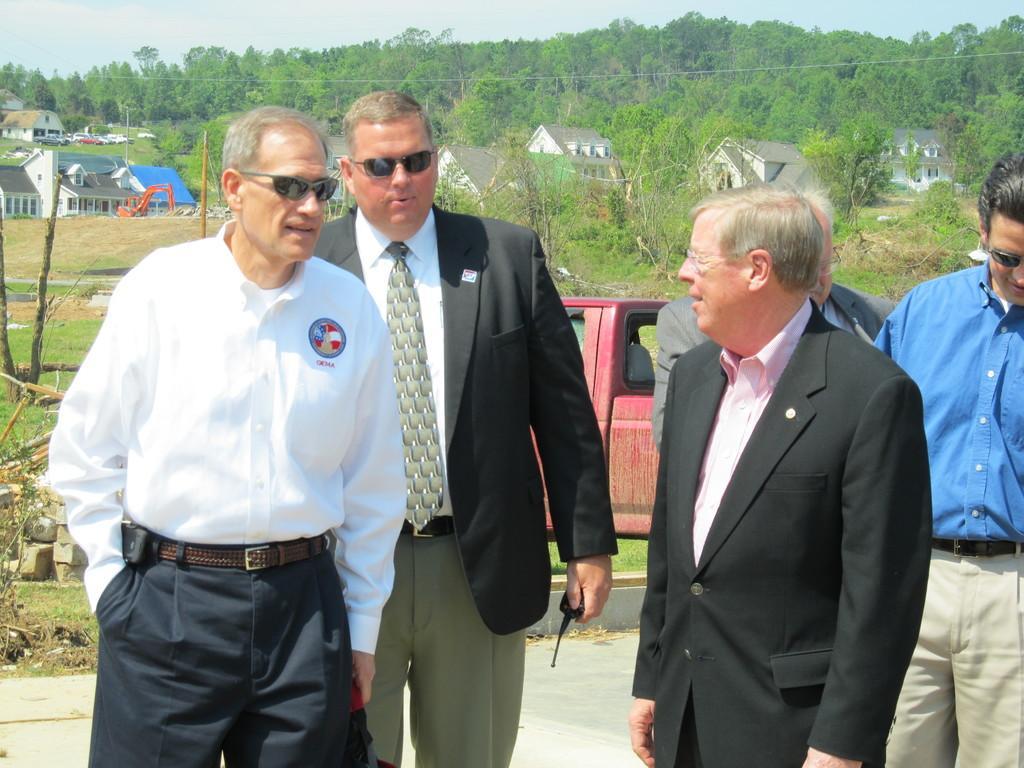In one or two sentences, can you explain what this image depicts? In the background we can see the sky, trees, houses, vehicles. It seems like an excavator. In this picture we can see the green grass, road, people standing. We can see a man wearing goggles, shirt, tie, blazer and he is holding a walkie-talkie in his hand. 